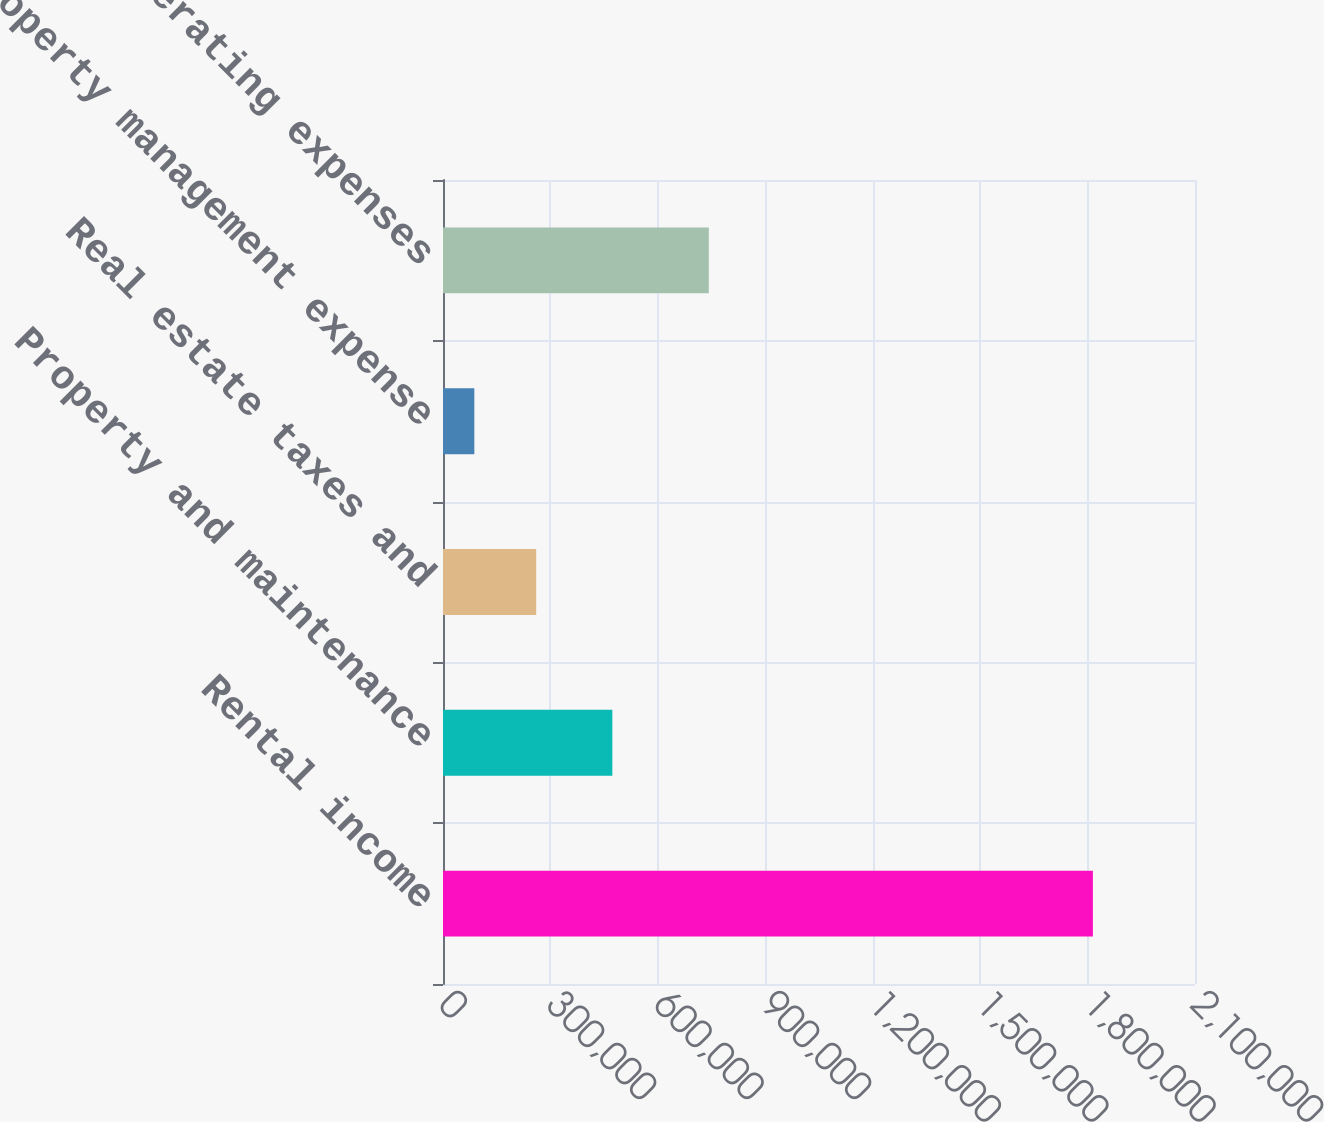Convert chart. <chart><loc_0><loc_0><loc_500><loc_500><bar_chart><fcel>Rental income<fcel>Property and maintenance<fcel>Real estate taxes and<fcel>Property management expense<fcel>Total operating expenses<nl><fcel>1.81486e+06<fcel>472899<fcel>260215<fcel>87476<fcel>742262<nl></chart> 